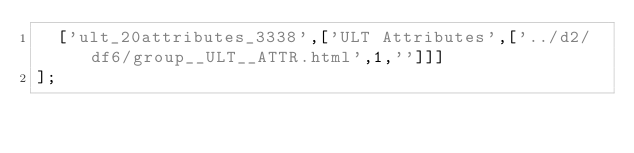Convert code to text. <code><loc_0><loc_0><loc_500><loc_500><_JavaScript_>  ['ult_20attributes_3338',['ULT Attributes',['../d2/df6/group__ULT__ATTR.html',1,'']]]
];
</code> 